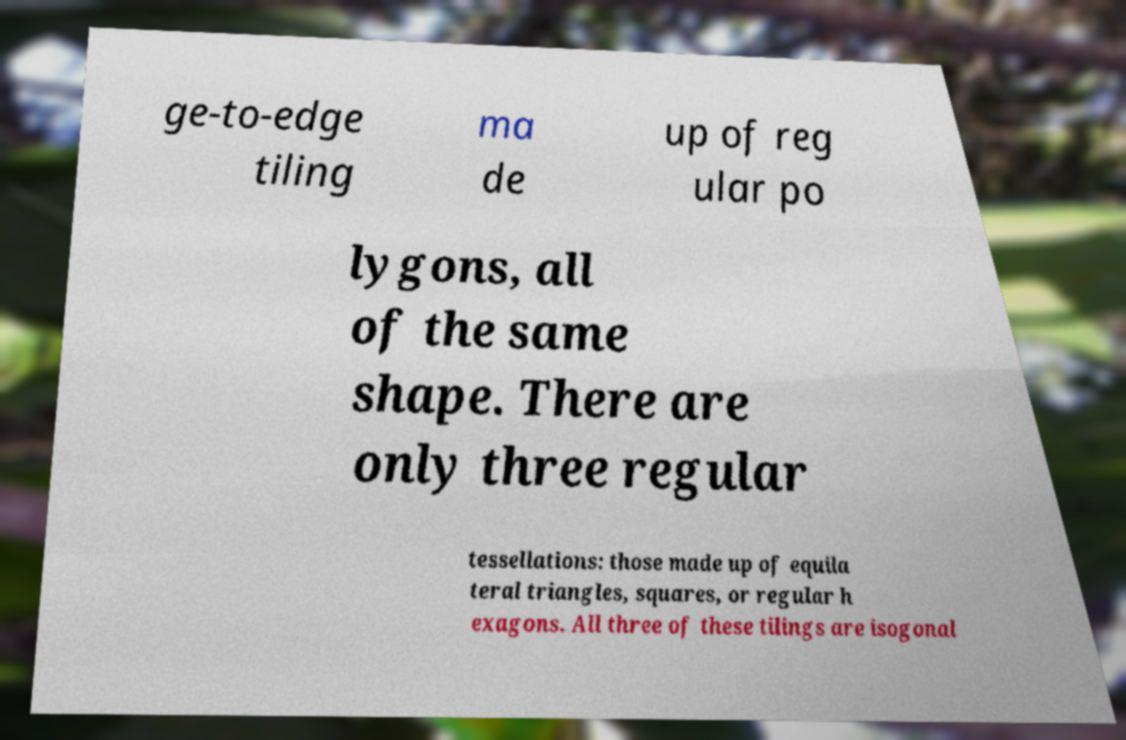Can you accurately transcribe the text from the provided image for me? ge-to-edge tiling ma de up of reg ular po lygons, all of the same shape. There are only three regular tessellations: those made up of equila teral triangles, squares, or regular h exagons. All three of these tilings are isogonal 